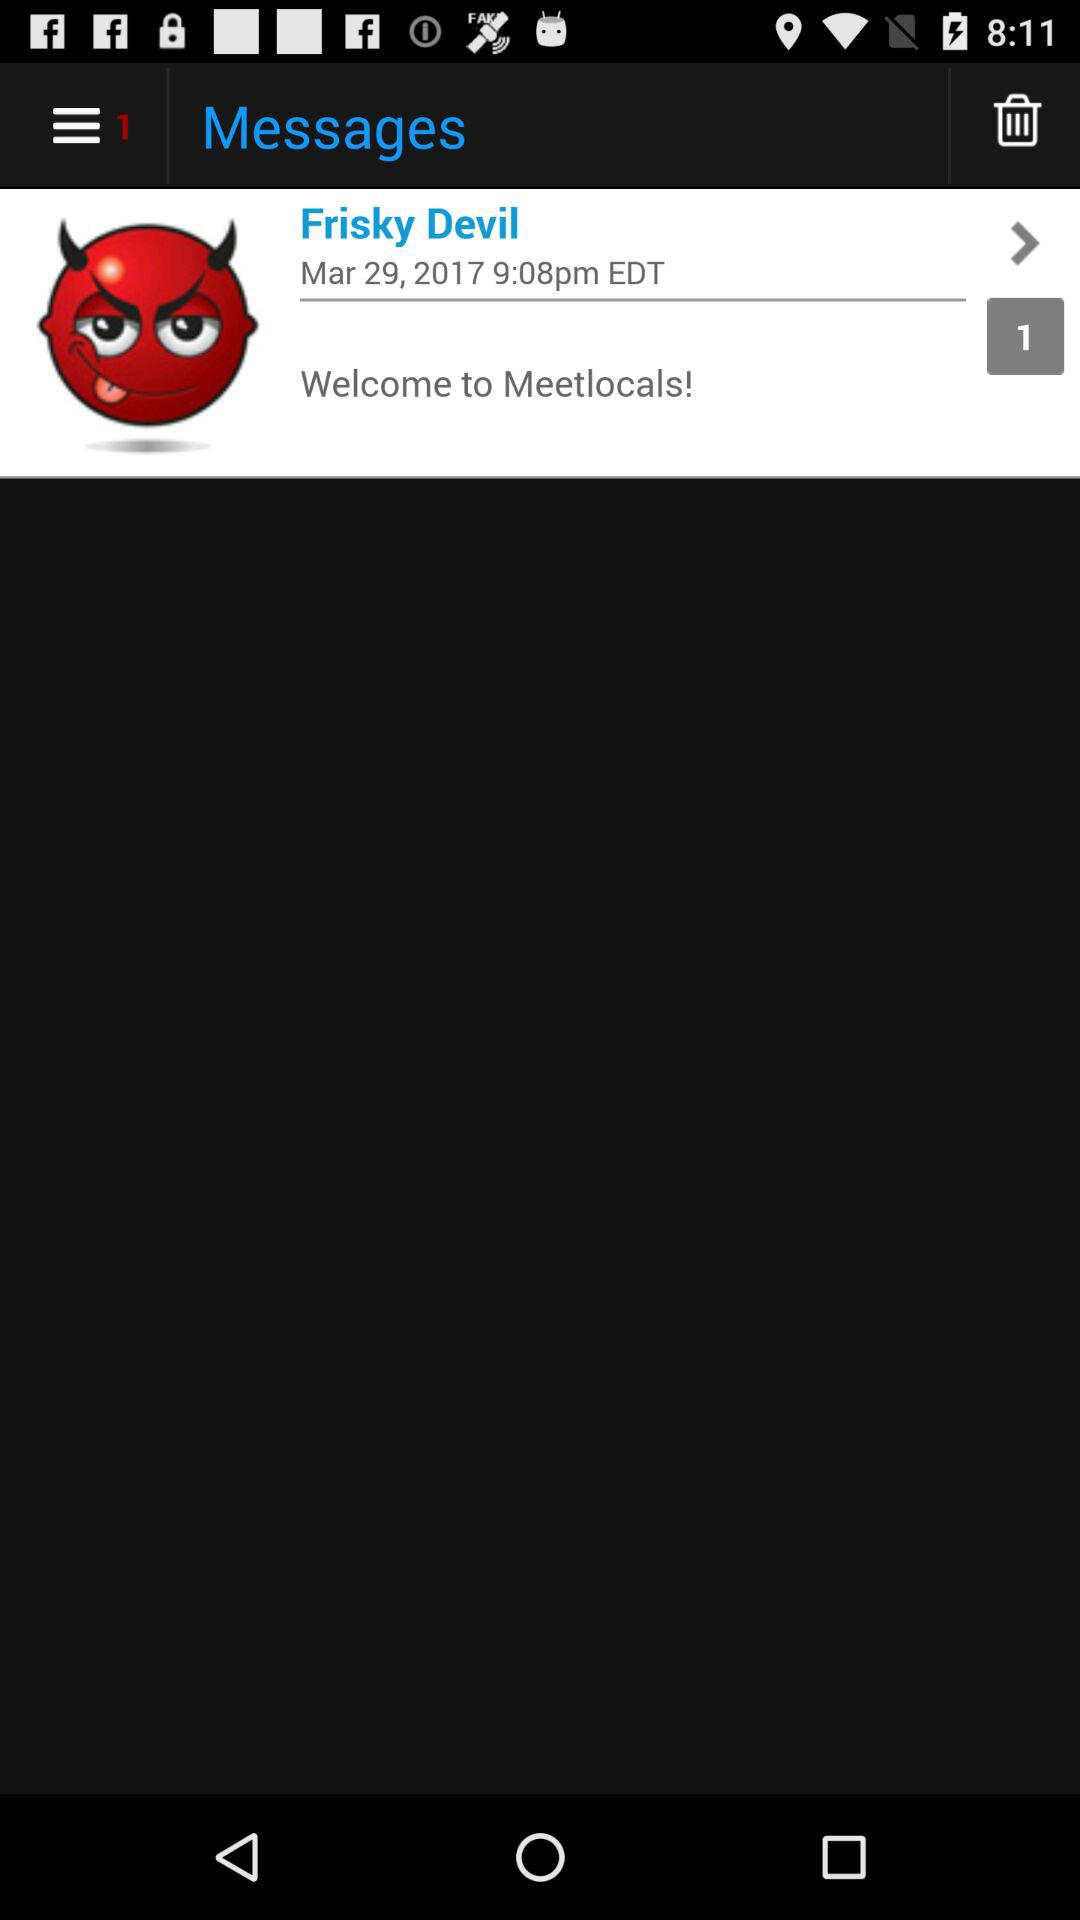What is the application name? The application name is "Messages". 